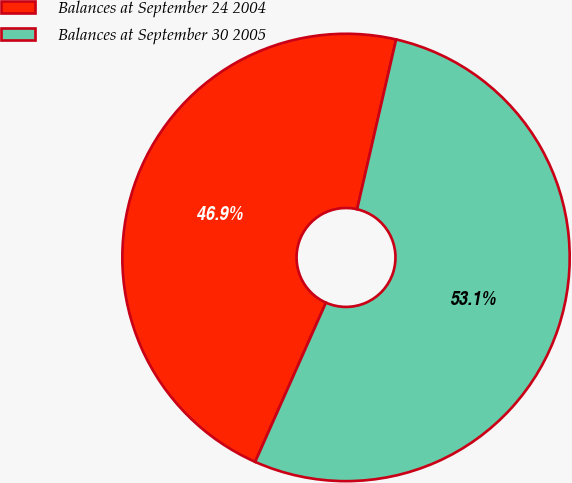Convert chart to OTSL. <chart><loc_0><loc_0><loc_500><loc_500><pie_chart><fcel>Balances at September 24 2004<fcel>Balances at September 30 2005<nl><fcel>46.94%<fcel>53.06%<nl></chart> 